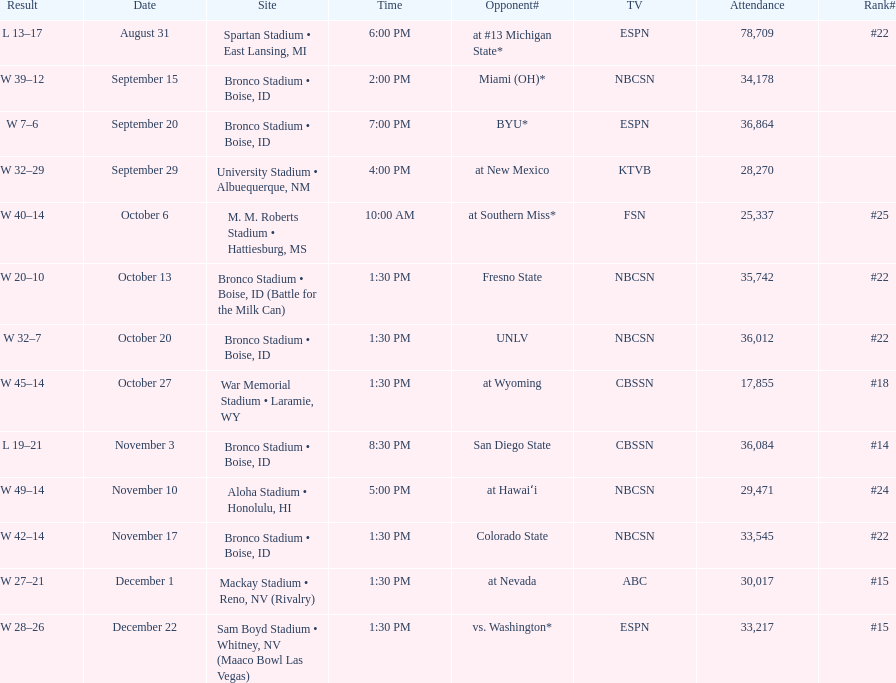Help me parse the entirety of this table. {'header': ['Result', 'Date', 'Site', 'Time', 'Opponent#', 'TV', 'Attendance', 'Rank#'], 'rows': [['L\xa013–17', 'August 31', 'Spartan Stadium • East Lansing, MI', '6:00 PM', 'at\xa0#13\xa0Michigan State*', 'ESPN', '78,709', '#22'], ['W\xa039–12', 'September 15', 'Bronco Stadium • Boise, ID', '2:00 PM', 'Miami (OH)*', 'NBCSN', '34,178', ''], ['W\xa07–6', 'September 20', 'Bronco Stadium • Boise, ID', '7:00 PM', 'BYU*', 'ESPN', '36,864', ''], ['W\xa032–29', 'September 29', 'University Stadium • Albuequerque, NM', '4:00 PM', 'at\xa0New Mexico', 'KTVB', '28,270', ''], ['W\xa040–14', 'October 6', 'M. M. Roberts Stadium • Hattiesburg, MS', '10:00 AM', 'at\xa0Southern Miss*', 'FSN', '25,337', '#25'], ['W\xa020–10', 'October 13', 'Bronco Stadium • Boise, ID (Battle for the Milk Can)', '1:30 PM', 'Fresno State', 'NBCSN', '35,742', '#22'], ['W\xa032–7', 'October 20', 'Bronco Stadium • Boise, ID', '1:30 PM', 'UNLV', 'NBCSN', '36,012', '#22'], ['W\xa045–14', 'October 27', 'War Memorial Stadium • Laramie, WY', '1:30 PM', 'at\xa0Wyoming', 'CBSSN', '17,855', '#18'], ['L\xa019–21', 'November 3', 'Bronco Stadium • Boise, ID', '8:30 PM', 'San Diego State', 'CBSSN', '36,084', '#14'], ['W\xa049–14', 'November 10', 'Aloha Stadium • Honolulu, HI', '5:00 PM', 'at\xa0Hawaiʻi', 'NBCSN', '29,471', '#24'], ['W\xa042–14', 'November 17', 'Bronco Stadium • Boise, ID', '1:30 PM', 'Colorado State', 'NBCSN', '33,545', '#22'], ['W\xa027–21', 'December 1', 'Mackay Stadium • Reno, NV (Rivalry)', '1:30 PM', 'at\xa0Nevada', 'ABC', '30,017', '#15'], ['W\xa028–26', 'December 22', 'Sam Boyd Stadium • Whitney, NV (Maaco Bowl Las Vegas)', '1:30 PM', 'vs.\xa0Washington*', 'ESPN', '33,217', '#15']]} Which team has the highest rank among those listed? San Diego State. 